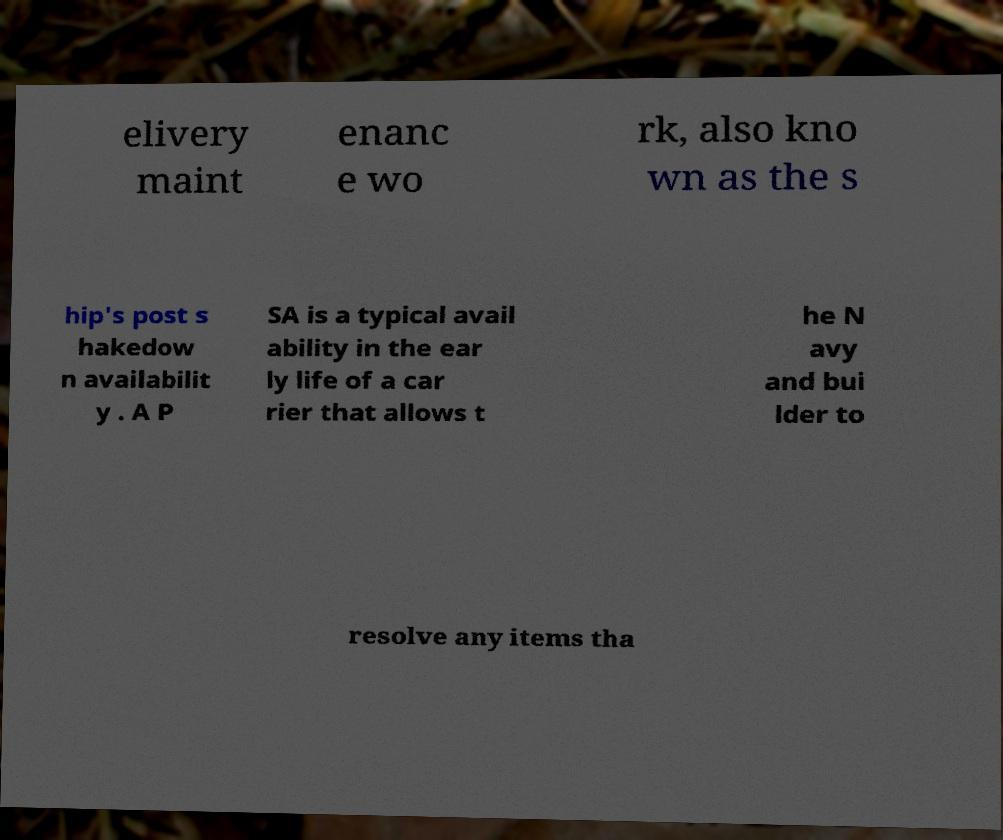Could you extract and type out the text from this image? elivery maint enanc e wo rk, also kno wn as the s hip's post s hakedow n availabilit y . A P SA is a typical avail ability in the ear ly life of a car rier that allows t he N avy and bui lder to resolve any items tha 